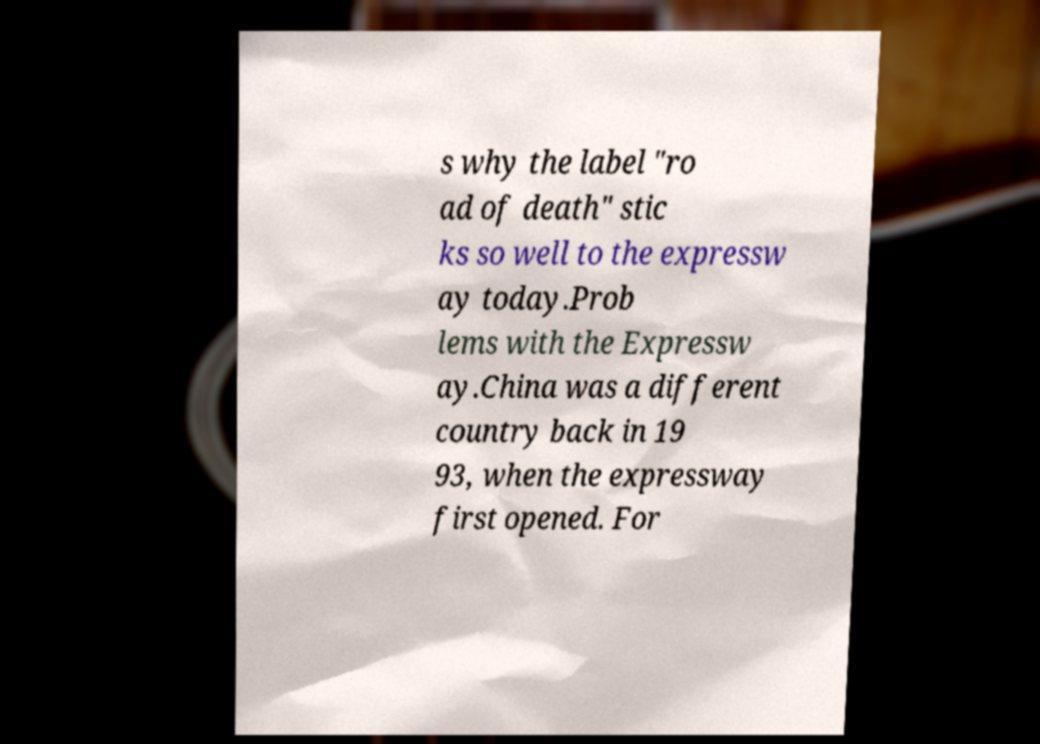Please identify and transcribe the text found in this image. s why the label "ro ad of death" stic ks so well to the expressw ay today.Prob lems with the Expressw ay.China was a different country back in 19 93, when the expressway first opened. For 